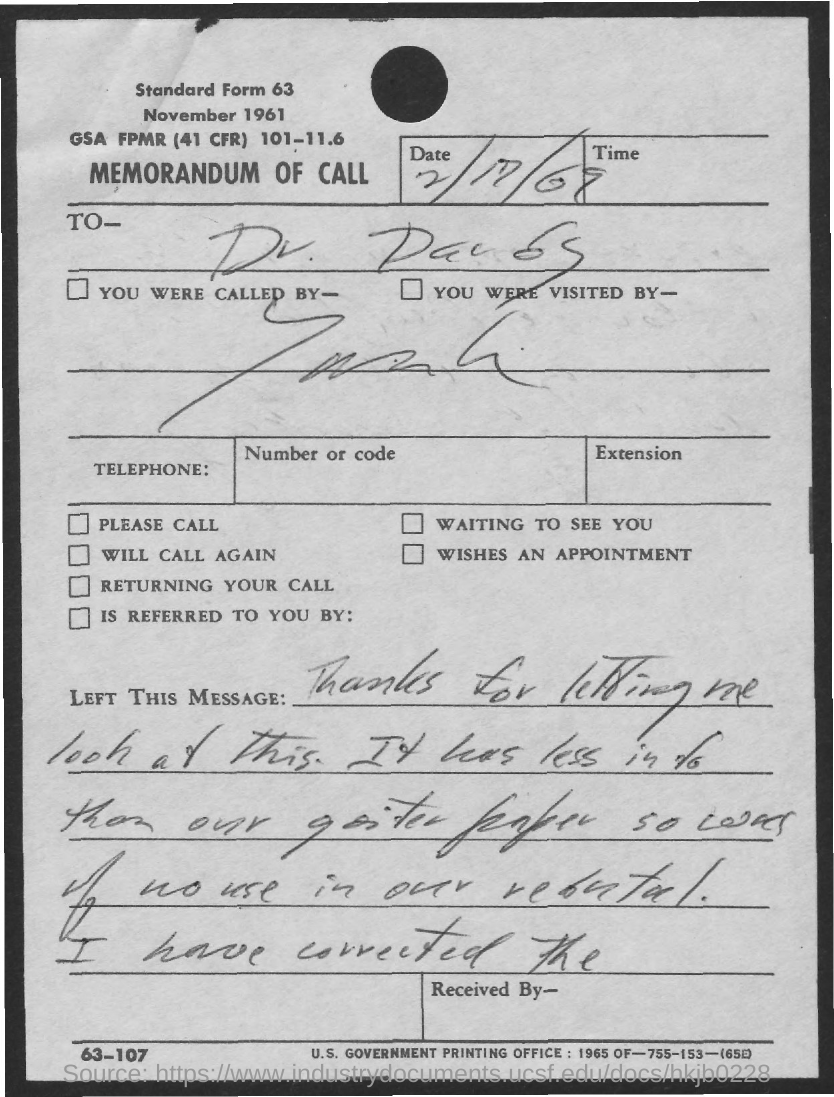Identify some key points in this picture. The date mentioned is 2/17/69. 